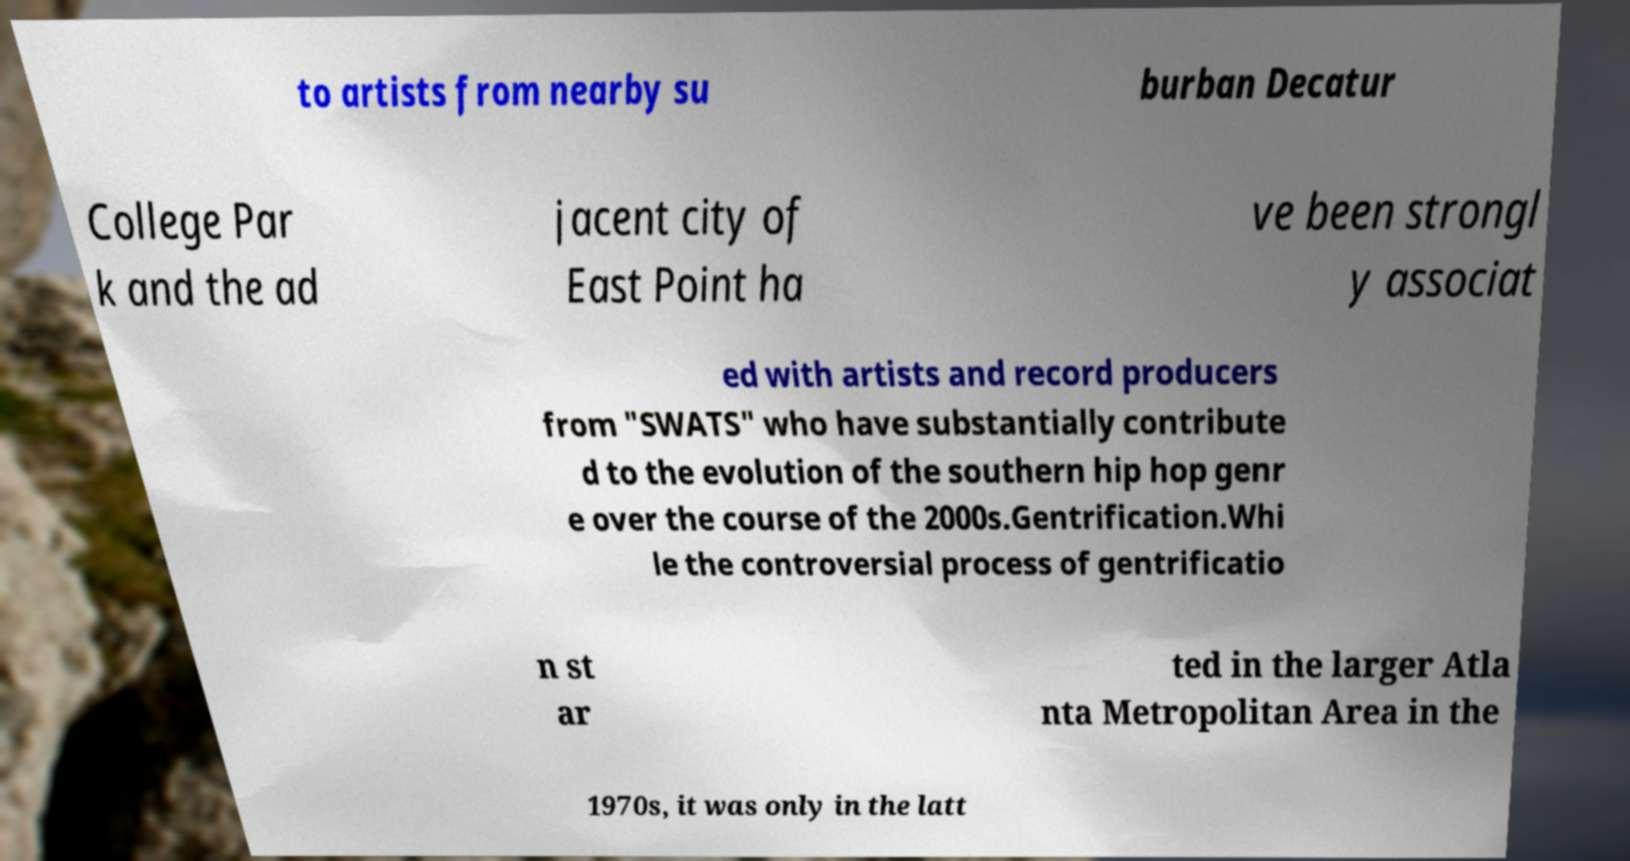Can you accurately transcribe the text from the provided image for me? to artists from nearby su burban Decatur College Par k and the ad jacent city of East Point ha ve been strongl y associat ed with artists and record producers from "SWATS" who have substantially contribute d to the evolution of the southern hip hop genr e over the course of the 2000s.Gentrification.Whi le the controversial process of gentrificatio n st ar ted in the larger Atla nta Metropolitan Area in the 1970s, it was only in the latt 